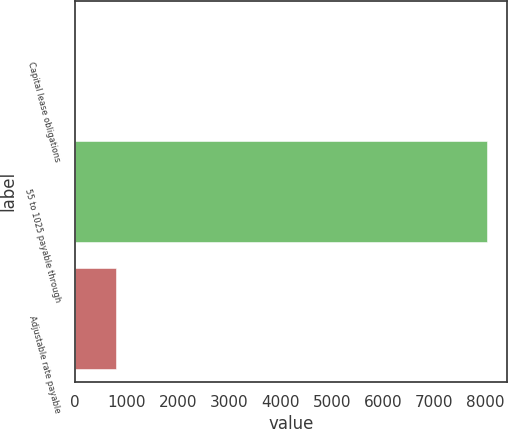<chart> <loc_0><loc_0><loc_500><loc_500><bar_chart><fcel>Capital lease obligations<fcel>55 to 1025 payable through<fcel>Adjustable rate payable<nl><fcel>3<fcel>8023<fcel>805<nl></chart> 